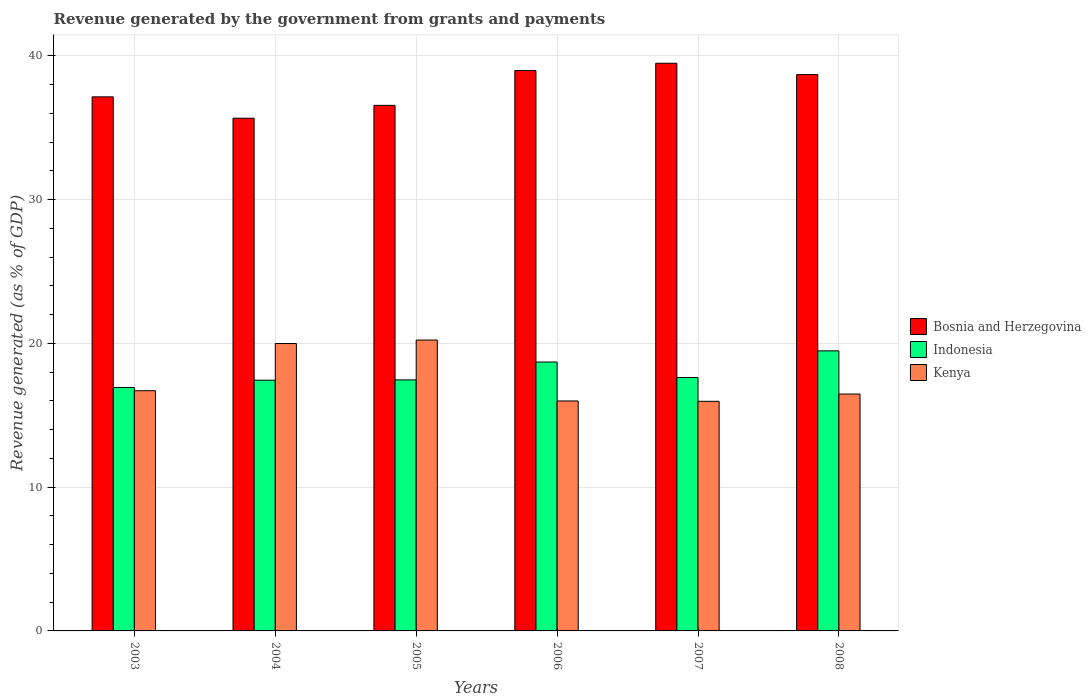Are the number of bars per tick equal to the number of legend labels?
Your response must be concise. Yes. Are the number of bars on each tick of the X-axis equal?
Your response must be concise. Yes. How many bars are there on the 5th tick from the left?
Keep it short and to the point. 3. How many bars are there on the 3rd tick from the right?
Give a very brief answer. 3. What is the label of the 4th group of bars from the left?
Offer a very short reply. 2006. What is the revenue generated by the government in Kenya in 2008?
Your answer should be very brief. 16.47. Across all years, what is the maximum revenue generated by the government in Indonesia?
Ensure brevity in your answer.  19.48. Across all years, what is the minimum revenue generated by the government in Bosnia and Herzegovina?
Ensure brevity in your answer.  35.66. In which year was the revenue generated by the government in Kenya maximum?
Ensure brevity in your answer.  2005. In which year was the revenue generated by the government in Bosnia and Herzegovina minimum?
Your answer should be compact. 2004. What is the total revenue generated by the government in Indonesia in the graph?
Give a very brief answer. 107.62. What is the difference between the revenue generated by the government in Kenya in 2006 and that in 2007?
Give a very brief answer. 0.02. What is the difference between the revenue generated by the government in Kenya in 2003 and the revenue generated by the government in Indonesia in 2005?
Offer a terse response. -0.75. What is the average revenue generated by the government in Bosnia and Herzegovina per year?
Your answer should be compact. 37.75. In the year 2007, what is the difference between the revenue generated by the government in Bosnia and Herzegovina and revenue generated by the government in Indonesia?
Ensure brevity in your answer.  21.85. In how many years, is the revenue generated by the government in Indonesia greater than 22 %?
Offer a terse response. 0. What is the ratio of the revenue generated by the government in Bosnia and Herzegovina in 2003 to that in 2008?
Give a very brief answer. 0.96. What is the difference between the highest and the second highest revenue generated by the government in Indonesia?
Your answer should be compact. 0.78. What is the difference between the highest and the lowest revenue generated by the government in Kenya?
Ensure brevity in your answer.  4.26. What does the 3rd bar from the right in 2006 represents?
Provide a succinct answer. Bosnia and Herzegovina. How many bars are there?
Provide a short and direct response. 18. How many years are there in the graph?
Ensure brevity in your answer.  6. What is the difference between two consecutive major ticks on the Y-axis?
Give a very brief answer. 10. Does the graph contain any zero values?
Keep it short and to the point. No. Does the graph contain grids?
Your answer should be compact. Yes. How many legend labels are there?
Ensure brevity in your answer.  3. How are the legend labels stacked?
Offer a very short reply. Vertical. What is the title of the graph?
Your response must be concise. Revenue generated by the government from grants and payments. What is the label or title of the X-axis?
Make the answer very short. Years. What is the label or title of the Y-axis?
Offer a very short reply. Revenue generated (as % of GDP). What is the Revenue generated (as % of GDP) of Bosnia and Herzegovina in 2003?
Keep it short and to the point. 37.14. What is the Revenue generated (as % of GDP) of Indonesia in 2003?
Your answer should be very brief. 16.93. What is the Revenue generated (as % of GDP) of Kenya in 2003?
Offer a very short reply. 16.7. What is the Revenue generated (as % of GDP) of Bosnia and Herzegovina in 2004?
Your response must be concise. 35.66. What is the Revenue generated (as % of GDP) in Indonesia in 2004?
Your answer should be very brief. 17.44. What is the Revenue generated (as % of GDP) in Kenya in 2004?
Offer a very short reply. 19.99. What is the Revenue generated (as % of GDP) in Bosnia and Herzegovina in 2005?
Make the answer very short. 36.55. What is the Revenue generated (as % of GDP) in Indonesia in 2005?
Offer a very short reply. 17.46. What is the Revenue generated (as % of GDP) of Kenya in 2005?
Your answer should be very brief. 20.23. What is the Revenue generated (as % of GDP) in Bosnia and Herzegovina in 2006?
Provide a short and direct response. 38.97. What is the Revenue generated (as % of GDP) of Indonesia in 2006?
Provide a short and direct response. 18.7. What is the Revenue generated (as % of GDP) in Kenya in 2006?
Your response must be concise. 15.99. What is the Revenue generated (as % of GDP) of Bosnia and Herzegovina in 2007?
Provide a short and direct response. 39.48. What is the Revenue generated (as % of GDP) in Indonesia in 2007?
Keep it short and to the point. 17.62. What is the Revenue generated (as % of GDP) of Kenya in 2007?
Keep it short and to the point. 15.97. What is the Revenue generated (as % of GDP) in Bosnia and Herzegovina in 2008?
Your response must be concise. 38.69. What is the Revenue generated (as % of GDP) of Indonesia in 2008?
Your answer should be compact. 19.48. What is the Revenue generated (as % of GDP) in Kenya in 2008?
Ensure brevity in your answer.  16.47. Across all years, what is the maximum Revenue generated (as % of GDP) in Bosnia and Herzegovina?
Your response must be concise. 39.48. Across all years, what is the maximum Revenue generated (as % of GDP) in Indonesia?
Your answer should be compact. 19.48. Across all years, what is the maximum Revenue generated (as % of GDP) in Kenya?
Offer a terse response. 20.23. Across all years, what is the minimum Revenue generated (as % of GDP) of Bosnia and Herzegovina?
Your answer should be compact. 35.66. Across all years, what is the minimum Revenue generated (as % of GDP) in Indonesia?
Give a very brief answer. 16.93. Across all years, what is the minimum Revenue generated (as % of GDP) of Kenya?
Provide a short and direct response. 15.97. What is the total Revenue generated (as % of GDP) in Bosnia and Herzegovina in the graph?
Your response must be concise. 226.48. What is the total Revenue generated (as % of GDP) in Indonesia in the graph?
Offer a terse response. 107.62. What is the total Revenue generated (as % of GDP) in Kenya in the graph?
Your response must be concise. 105.35. What is the difference between the Revenue generated (as % of GDP) of Bosnia and Herzegovina in 2003 and that in 2004?
Make the answer very short. 1.48. What is the difference between the Revenue generated (as % of GDP) of Indonesia in 2003 and that in 2004?
Offer a terse response. -0.51. What is the difference between the Revenue generated (as % of GDP) of Kenya in 2003 and that in 2004?
Give a very brief answer. -3.28. What is the difference between the Revenue generated (as % of GDP) in Bosnia and Herzegovina in 2003 and that in 2005?
Provide a succinct answer. 0.59. What is the difference between the Revenue generated (as % of GDP) of Indonesia in 2003 and that in 2005?
Your answer should be very brief. -0.53. What is the difference between the Revenue generated (as % of GDP) of Kenya in 2003 and that in 2005?
Your response must be concise. -3.52. What is the difference between the Revenue generated (as % of GDP) of Bosnia and Herzegovina in 2003 and that in 2006?
Offer a terse response. -1.83. What is the difference between the Revenue generated (as % of GDP) of Indonesia in 2003 and that in 2006?
Your answer should be very brief. -1.77. What is the difference between the Revenue generated (as % of GDP) of Kenya in 2003 and that in 2006?
Your answer should be very brief. 0.71. What is the difference between the Revenue generated (as % of GDP) of Bosnia and Herzegovina in 2003 and that in 2007?
Give a very brief answer. -2.34. What is the difference between the Revenue generated (as % of GDP) in Indonesia in 2003 and that in 2007?
Provide a succinct answer. -0.69. What is the difference between the Revenue generated (as % of GDP) in Kenya in 2003 and that in 2007?
Keep it short and to the point. 0.74. What is the difference between the Revenue generated (as % of GDP) of Bosnia and Herzegovina in 2003 and that in 2008?
Your answer should be compact. -1.55. What is the difference between the Revenue generated (as % of GDP) in Indonesia in 2003 and that in 2008?
Your answer should be compact. -2.55. What is the difference between the Revenue generated (as % of GDP) of Kenya in 2003 and that in 2008?
Keep it short and to the point. 0.23. What is the difference between the Revenue generated (as % of GDP) of Bosnia and Herzegovina in 2004 and that in 2005?
Your answer should be very brief. -0.89. What is the difference between the Revenue generated (as % of GDP) in Indonesia in 2004 and that in 2005?
Provide a succinct answer. -0.02. What is the difference between the Revenue generated (as % of GDP) in Kenya in 2004 and that in 2005?
Offer a very short reply. -0.24. What is the difference between the Revenue generated (as % of GDP) in Bosnia and Herzegovina in 2004 and that in 2006?
Provide a short and direct response. -3.31. What is the difference between the Revenue generated (as % of GDP) of Indonesia in 2004 and that in 2006?
Your response must be concise. -1.26. What is the difference between the Revenue generated (as % of GDP) of Kenya in 2004 and that in 2006?
Make the answer very short. 3.99. What is the difference between the Revenue generated (as % of GDP) of Bosnia and Herzegovina in 2004 and that in 2007?
Make the answer very short. -3.82. What is the difference between the Revenue generated (as % of GDP) in Indonesia in 2004 and that in 2007?
Provide a succinct answer. -0.19. What is the difference between the Revenue generated (as % of GDP) of Kenya in 2004 and that in 2007?
Your answer should be compact. 4.02. What is the difference between the Revenue generated (as % of GDP) in Bosnia and Herzegovina in 2004 and that in 2008?
Offer a very short reply. -3.03. What is the difference between the Revenue generated (as % of GDP) of Indonesia in 2004 and that in 2008?
Give a very brief answer. -2.04. What is the difference between the Revenue generated (as % of GDP) in Kenya in 2004 and that in 2008?
Ensure brevity in your answer.  3.51. What is the difference between the Revenue generated (as % of GDP) of Bosnia and Herzegovina in 2005 and that in 2006?
Make the answer very short. -2.42. What is the difference between the Revenue generated (as % of GDP) of Indonesia in 2005 and that in 2006?
Your answer should be very brief. -1.24. What is the difference between the Revenue generated (as % of GDP) of Kenya in 2005 and that in 2006?
Offer a very short reply. 4.24. What is the difference between the Revenue generated (as % of GDP) in Bosnia and Herzegovina in 2005 and that in 2007?
Provide a succinct answer. -2.93. What is the difference between the Revenue generated (as % of GDP) of Indonesia in 2005 and that in 2007?
Your response must be concise. -0.17. What is the difference between the Revenue generated (as % of GDP) in Kenya in 2005 and that in 2007?
Provide a short and direct response. 4.26. What is the difference between the Revenue generated (as % of GDP) of Bosnia and Herzegovina in 2005 and that in 2008?
Your response must be concise. -2.14. What is the difference between the Revenue generated (as % of GDP) of Indonesia in 2005 and that in 2008?
Offer a terse response. -2.02. What is the difference between the Revenue generated (as % of GDP) of Kenya in 2005 and that in 2008?
Give a very brief answer. 3.76. What is the difference between the Revenue generated (as % of GDP) in Bosnia and Herzegovina in 2006 and that in 2007?
Offer a very short reply. -0.51. What is the difference between the Revenue generated (as % of GDP) in Indonesia in 2006 and that in 2007?
Offer a very short reply. 1.08. What is the difference between the Revenue generated (as % of GDP) in Kenya in 2006 and that in 2007?
Offer a terse response. 0.02. What is the difference between the Revenue generated (as % of GDP) of Bosnia and Herzegovina in 2006 and that in 2008?
Your answer should be very brief. 0.28. What is the difference between the Revenue generated (as % of GDP) of Indonesia in 2006 and that in 2008?
Make the answer very short. -0.78. What is the difference between the Revenue generated (as % of GDP) of Kenya in 2006 and that in 2008?
Offer a very short reply. -0.48. What is the difference between the Revenue generated (as % of GDP) of Bosnia and Herzegovina in 2007 and that in 2008?
Make the answer very short. 0.79. What is the difference between the Revenue generated (as % of GDP) of Indonesia in 2007 and that in 2008?
Your answer should be very brief. -1.85. What is the difference between the Revenue generated (as % of GDP) of Kenya in 2007 and that in 2008?
Your answer should be very brief. -0.5. What is the difference between the Revenue generated (as % of GDP) in Bosnia and Herzegovina in 2003 and the Revenue generated (as % of GDP) in Indonesia in 2004?
Offer a terse response. 19.7. What is the difference between the Revenue generated (as % of GDP) in Bosnia and Herzegovina in 2003 and the Revenue generated (as % of GDP) in Kenya in 2004?
Ensure brevity in your answer.  17.15. What is the difference between the Revenue generated (as % of GDP) of Indonesia in 2003 and the Revenue generated (as % of GDP) of Kenya in 2004?
Your answer should be compact. -3.06. What is the difference between the Revenue generated (as % of GDP) in Bosnia and Herzegovina in 2003 and the Revenue generated (as % of GDP) in Indonesia in 2005?
Ensure brevity in your answer.  19.68. What is the difference between the Revenue generated (as % of GDP) in Bosnia and Herzegovina in 2003 and the Revenue generated (as % of GDP) in Kenya in 2005?
Offer a very short reply. 16.91. What is the difference between the Revenue generated (as % of GDP) of Indonesia in 2003 and the Revenue generated (as % of GDP) of Kenya in 2005?
Give a very brief answer. -3.3. What is the difference between the Revenue generated (as % of GDP) of Bosnia and Herzegovina in 2003 and the Revenue generated (as % of GDP) of Indonesia in 2006?
Provide a short and direct response. 18.44. What is the difference between the Revenue generated (as % of GDP) in Bosnia and Herzegovina in 2003 and the Revenue generated (as % of GDP) in Kenya in 2006?
Make the answer very short. 21.15. What is the difference between the Revenue generated (as % of GDP) of Indonesia in 2003 and the Revenue generated (as % of GDP) of Kenya in 2006?
Offer a terse response. 0.94. What is the difference between the Revenue generated (as % of GDP) in Bosnia and Herzegovina in 2003 and the Revenue generated (as % of GDP) in Indonesia in 2007?
Provide a succinct answer. 19.52. What is the difference between the Revenue generated (as % of GDP) of Bosnia and Herzegovina in 2003 and the Revenue generated (as % of GDP) of Kenya in 2007?
Your answer should be compact. 21.17. What is the difference between the Revenue generated (as % of GDP) in Indonesia in 2003 and the Revenue generated (as % of GDP) in Kenya in 2007?
Give a very brief answer. 0.96. What is the difference between the Revenue generated (as % of GDP) of Bosnia and Herzegovina in 2003 and the Revenue generated (as % of GDP) of Indonesia in 2008?
Keep it short and to the point. 17.66. What is the difference between the Revenue generated (as % of GDP) in Bosnia and Herzegovina in 2003 and the Revenue generated (as % of GDP) in Kenya in 2008?
Offer a very short reply. 20.67. What is the difference between the Revenue generated (as % of GDP) in Indonesia in 2003 and the Revenue generated (as % of GDP) in Kenya in 2008?
Your answer should be compact. 0.46. What is the difference between the Revenue generated (as % of GDP) in Bosnia and Herzegovina in 2004 and the Revenue generated (as % of GDP) in Indonesia in 2005?
Make the answer very short. 18.2. What is the difference between the Revenue generated (as % of GDP) of Bosnia and Herzegovina in 2004 and the Revenue generated (as % of GDP) of Kenya in 2005?
Your answer should be very brief. 15.43. What is the difference between the Revenue generated (as % of GDP) of Indonesia in 2004 and the Revenue generated (as % of GDP) of Kenya in 2005?
Offer a terse response. -2.79. What is the difference between the Revenue generated (as % of GDP) of Bosnia and Herzegovina in 2004 and the Revenue generated (as % of GDP) of Indonesia in 2006?
Give a very brief answer. 16.96. What is the difference between the Revenue generated (as % of GDP) of Bosnia and Herzegovina in 2004 and the Revenue generated (as % of GDP) of Kenya in 2006?
Provide a short and direct response. 19.66. What is the difference between the Revenue generated (as % of GDP) in Indonesia in 2004 and the Revenue generated (as % of GDP) in Kenya in 2006?
Your response must be concise. 1.44. What is the difference between the Revenue generated (as % of GDP) of Bosnia and Herzegovina in 2004 and the Revenue generated (as % of GDP) of Indonesia in 2007?
Your answer should be very brief. 18.03. What is the difference between the Revenue generated (as % of GDP) in Bosnia and Herzegovina in 2004 and the Revenue generated (as % of GDP) in Kenya in 2007?
Give a very brief answer. 19.69. What is the difference between the Revenue generated (as % of GDP) in Indonesia in 2004 and the Revenue generated (as % of GDP) in Kenya in 2007?
Your response must be concise. 1.47. What is the difference between the Revenue generated (as % of GDP) of Bosnia and Herzegovina in 2004 and the Revenue generated (as % of GDP) of Indonesia in 2008?
Provide a succinct answer. 16.18. What is the difference between the Revenue generated (as % of GDP) in Bosnia and Herzegovina in 2004 and the Revenue generated (as % of GDP) in Kenya in 2008?
Provide a succinct answer. 19.18. What is the difference between the Revenue generated (as % of GDP) of Indonesia in 2004 and the Revenue generated (as % of GDP) of Kenya in 2008?
Give a very brief answer. 0.96. What is the difference between the Revenue generated (as % of GDP) of Bosnia and Herzegovina in 2005 and the Revenue generated (as % of GDP) of Indonesia in 2006?
Give a very brief answer. 17.85. What is the difference between the Revenue generated (as % of GDP) in Bosnia and Herzegovina in 2005 and the Revenue generated (as % of GDP) in Kenya in 2006?
Keep it short and to the point. 20.56. What is the difference between the Revenue generated (as % of GDP) of Indonesia in 2005 and the Revenue generated (as % of GDP) of Kenya in 2006?
Make the answer very short. 1.46. What is the difference between the Revenue generated (as % of GDP) of Bosnia and Herzegovina in 2005 and the Revenue generated (as % of GDP) of Indonesia in 2007?
Offer a very short reply. 18.93. What is the difference between the Revenue generated (as % of GDP) in Bosnia and Herzegovina in 2005 and the Revenue generated (as % of GDP) in Kenya in 2007?
Ensure brevity in your answer.  20.58. What is the difference between the Revenue generated (as % of GDP) in Indonesia in 2005 and the Revenue generated (as % of GDP) in Kenya in 2007?
Provide a short and direct response. 1.49. What is the difference between the Revenue generated (as % of GDP) of Bosnia and Herzegovina in 2005 and the Revenue generated (as % of GDP) of Indonesia in 2008?
Give a very brief answer. 17.07. What is the difference between the Revenue generated (as % of GDP) in Bosnia and Herzegovina in 2005 and the Revenue generated (as % of GDP) in Kenya in 2008?
Offer a terse response. 20.08. What is the difference between the Revenue generated (as % of GDP) in Indonesia in 2005 and the Revenue generated (as % of GDP) in Kenya in 2008?
Provide a short and direct response. 0.98. What is the difference between the Revenue generated (as % of GDP) in Bosnia and Herzegovina in 2006 and the Revenue generated (as % of GDP) in Indonesia in 2007?
Your response must be concise. 21.35. What is the difference between the Revenue generated (as % of GDP) of Bosnia and Herzegovina in 2006 and the Revenue generated (as % of GDP) of Kenya in 2007?
Provide a succinct answer. 23. What is the difference between the Revenue generated (as % of GDP) of Indonesia in 2006 and the Revenue generated (as % of GDP) of Kenya in 2007?
Your answer should be compact. 2.73. What is the difference between the Revenue generated (as % of GDP) of Bosnia and Herzegovina in 2006 and the Revenue generated (as % of GDP) of Indonesia in 2008?
Make the answer very short. 19.49. What is the difference between the Revenue generated (as % of GDP) in Bosnia and Herzegovina in 2006 and the Revenue generated (as % of GDP) in Kenya in 2008?
Make the answer very short. 22.5. What is the difference between the Revenue generated (as % of GDP) in Indonesia in 2006 and the Revenue generated (as % of GDP) in Kenya in 2008?
Ensure brevity in your answer.  2.23. What is the difference between the Revenue generated (as % of GDP) of Bosnia and Herzegovina in 2007 and the Revenue generated (as % of GDP) of Indonesia in 2008?
Provide a succinct answer. 20. What is the difference between the Revenue generated (as % of GDP) of Bosnia and Herzegovina in 2007 and the Revenue generated (as % of GDP) of Kenya in 2008?
Your answer should be compact. 23. What is the difference between the Revenue generated (as % of GDP) of Indonesia in 2007 and the Revenue generated (as % of GDP) of Kenya in 2008?
Keep it short and to the point. 1.15. What is the average Revenue generated (as % of GDP) of Bosnia and Herzegovina per year?
Provide a succinct answer. 37.75. What is the average Revenue generated (as % of GDP) in Indonesia per year?
Offer a terse response. 17.94. What is the average Revenue generated (as % of GDP) in Kenya per year?
Provide a short and direct response. 17.56. In the year 2003, what is the difference between the Revenue generated (as % of GDP) in Bosnia and Herzegovina and Revenue generated (as % of GDP) in Indonesia?
Your answer should be very brief. 20.21. In the year 2003, what is the difference between the Revenue generated (as % of GDP) of Bosnia and Herzegovina and Revenue generated (as % of GDP) of Kenya?
Offer a terse response. 20.44. In the year 2003, what is the difference between the Revenue generated (as % of GDP) of Indonesia and Revenue generated (as % of GDP) of Kenya?
Offer a very short reply. 0.22. In the year 2004, what is the difference between the Revenue generated (as % of GDP) of Bosnia and Herzegovina and Revenue generated (as % of GDP) of Indonesia?
Offer a terse response. 18.22. In the year 2004, what is the difference between the Revenue generated (as % of GDP) in Bosnia and Herzegovina and Revenue generated (as % of GDP) in Kenya?
Your response must be concise. 15.67. In the year 2004, what is the difference between the Revenue generated (as % of GDP) of Indonesia and Revenue generated (as % of GDP) of Kenya?
Give a very brief answer. -2.55. In the year 2005, what is the difference between the Revenue generated (as % of GDP) of Bosnia and Herzegovina and Revenue generated (as % of GDP) of Indonesia?
Your answer should be very brief. 19.09. In the year 2005, what is the difference between the Revenue generated (as % of GDP) in Bosnia and Herzegovina and Revenue generated (as % of GDP) in Kenya?
Give a very brief answer. 16.32. In the year 2005, what is the difference between the Revenue generated (as % of GDP) in Indonesia and Revenue generated (as % of GDP) in Kenya?
Provide a succinct answer. -2.77. In the year 2006, what is the difference between the Revenue generated (as % of GDP) of Bosnia and Herzegovina and Revenue generated (as % of GDP) of Indonesia?
Your response must be concise. 20.27. In the year 2006, what is the difference between the Revenue generated (as % of GDP) of Bosnia and Herzegovina and Revenue generated (as % of GDP) of Kenya?
Offer a very short reply. 22.98. In the year 2006, what is the difference between the Revenue generated (as % of GDP) in Indonesia and Revenue generated (as % of GDP) in Kenya?
Your response must be concise. 2.71. In the year 2007, what is the difference between the Revenue generated (as % of GDP) in Bosnia and Herzegovina and Revenue generated (as % of GDP) in Indonesia?
Give a very brief answer. 21.86. In the year 2007, what is the difference between the Revenue generated (as % of GDP) in Bosnia and Herzegovina and Revenue generated (as % of GDP) in Kenya?
Your response must be concise. 23.51. In the year 2007, what is the difference between the Revenue generated (as % of GDP) in Indonesia and Revenue generated (as % of GDP) in Kenya?
Offer a very short reply. 1.65. In the year 2008, what is the difference between the Revenue generated (as % of GDP) in Bosnia and Herzegovina and Revenue generated (as % of GDP) in Indonesia?
Provide a short and direct response. 19.21. In the year 2008, what is the difference between the Revenue generated (as % of GDP) in Bosnia and Herzegovina and Revenue generated (as % of GDP) in Kenya?
Your answer should be compact. 22.22. In the year 2008, what is the difference between the Revenue generated (as % of GDP) in Indonesia and Revenue generated (as % of GDP) in Kenya?
Your answer should be very brief. 3. What is the ratio of the Revenue generated (as % of GDP) in Bosnia and Herzegovina in 2003 to that in 2004?
Offer a very short reply. 1.04. What is the ratio of the Revenue generated (as % of GDP) of Indonesia in 2003 to that in 2004?
Provide a short and direct response. 0.97. What is the ratio of the Revenue generated (as % of GDP) in Kenya in 2003 to that in 2004?
Your answer should be very brief. 0.84. What is the ratio of the Revenue generated (as % of GDP) in Bosnia and Herzegovina in 2003 to that in 2005?
Make the answer very short. 1.02. What is the ratio of the Revenue generated (as % of GDP) in Indonesia in 2003 to that in 2005?
Offer a very short reply. 0.97. What is the ratio of the Revenue generated (as % of GDP) of Kenya in 2003 to that in 2005?
Provide a succinct answer. 0.83. What is the ratio of the Revenue generated (as % of GDP) of Bosnia and Herzegovina in 2003 to that in 2006?
Your answer should be compact. 0.95. What is the ratio of the Revenue generated (as % of GDP) of Indonesia in 2003 to that in 2006?
Keep it short and to the point. 0.91. What is the ratio of the Revenue generated (as % of GDP) of Kenya in 2003 to that in 2006?
Your answer should be very brief. 1.04. What is the ratio of the Revenue generated (as % of GDP) in Bosnia and Herzegovina in 2003 to that in 2007?
Give a very brief answer. 0.94. What is the ratio of the Revenue generated (as % of GDP) of Indonesia in 2003 to that in 2007?
Provide a short and direct response. 0.96. What is the ratio of the Revenue generated (as % of GDP) of Kenya in 2003 to that in 2007?
Your response must be concise. 1.05. What is the ratio of the Revenue generated (as % of GDP) of Bosnia and Herzegovina in 2003 to that in 2008?
Make the answer very short. 0.96. What is the ratio of the Revenue generated (as % of GDP) of Indonesia in 2003 to that in 2008?
Offer a terse response. 0.87. What is the ratio of the Revenue generated (as % of GDP) of Kenya in 2003 to that in 2008?
Make the answer very short. 1.01. What is the ratio of the Revenue generated (as % of GDP) of Bosnia and Herzegovina in 2004 to that in 2005?
Give a very brief answer. 0.98. What is the ratio of the Revenue generated (as % of GDP) in Indonesia in 2004 to that in 2005?
Your response must be concise. 1. What is the ratio of the Revenue generated (as % of GDP) in Bosnia and Herzegovina in 2004 to that in 2006?
Ensure brevity in your answer.  0.92. What is the ratio of the Revenue generated (as % of GDP) of Indonesia in 2004 to that in 2006?
Your answer should be very brief. 0.93. What is the ratio of the Revenue generated (as % of GDP) of Kenya in 2004 to that in 2006?
Provide a succinct answer. 1.25. What is the ratio of the Revenue generated (as % of GDP) of Bosnia and Herzegovina in 2004 to that in 2007?
Ensure brevity in your answer.  0.9. What is the ratio of the Revenue generated (as % of GDP) of Indonesia in 2004 to that in 2007?
Your response must be concise. 0.99. What is the ratio of the Revenue generated (as % of GDP) in Kenya in 2004 to that in 2007?
Your answer should be compact. 1.25. What is the ratio of the Revenue generated (as % of GDP) in Bosnia and Herzegovina in 2004 to that in 2008?
Your answer should be compact. 0.92. What is the ratio of the Revenue generated (as % of GDP) in Indonesia in 2004 to that in 2008?
Ensure brevity in your answer.  0.9. What is the ratio of the Revenue generated (as % of GDP) of Kenya in 2004 to that in 2008?
Make the answer very short. 1.21. What is the ratio of the Revenue generated (as % of GDP) of Bosnia and Herzegovina in 2005 to that in 2006?
Ensure brevity in your answer.  0.94. What is the ratio of the Revenue generated (as % of GDP) in Indonesia in 2005 to that in 2006?
Keep it short and to the point. 0.93. What is the ratio of the Revenue generated (as % of GDP) of Kenya in 2005 to that in 2006?
Provide a succinct answer. 1.26. What is the ratio of the Revenue generated (as % of GDP) in Bosnia and Herzegovina in 2005 to that in 2007?
Make the answer very short. 0.93. What is the ratio of the Revenue generated (as % of GDP) of Indonesia in 2005 to that in 2007?
Offer a terse response. 0.99. What is the ratio of the Revenue generated (as % of GDP) of Kenya in 2005 to that in 2007?
Offer a terse response. 1.27. What is the ratio of the Revenue generated (as % of GDP) of Bosnia and Herzegovina in 2005 to that in 2008?
Your answer should be very brief. 0.94. What is the ratio of the Revenue generated (as % of GDP) of Indonesia in 2005 to that in 2008?
Keep it short and to the point. 0.9. What is the ratio of the Revenue generated (as % of GDP) of Kenya in 2005 to that in 2008?
Make the answer very short. 1.23. What is the ratio of the Revenue generated (as % of GDP) in Bosnia and Herzegovina in 2006 to that in 2007?
Offer a very short reply. 0.99. What is the ratio of the Revenue generated (as % of GDP) of Indonesia in 2006 to that in 2007?
Keep it short and to the point. 1.06. What is the ratio of the Revenue generated (as % of GDP) of Indonesia in 2006 to that in 2008?
Offer a very short reply. 0.96. What is the ratio of the Revenue generated (as % of GDP) in Kenya in 2006 to that in 2008?
Ensure brevity in your answer.  0.97. What is the ratio of the Revenue generated (as % of GDP) of Bosnia and Herzegovina in 2007 to that in 2008?
Your answer should be compact. 1.02. What is the ratio of the Revenue generated (as % of GDP) in Indonesia in 2007 to that in 2008?
Ensure brevity in your answer.  0.9. What is the ratio of the Revenue generated (as % of GDP) of Kenya in 2007 to that in 2008?
Offer a terse response. 0.97. What is the difference between the highest and the second highest Revenue generated (as % of GDP) in Bosnia and Herzegovina?
Offer a very short reply. 0.51. What is the difference between the highest and the second highest Revenue generated (as % of GDP) in Indonesia?
Provide a short and direct response. 0.78. What is the difference between the highest and the second highest Revenue generated (as % of GDP) in Kenya?
Provide a short and direct response. 0.24. What is the difference between the highest and the lowest Revenue generated (as % of GDP) of Bosnia and Herzegovina?
Your answer should be very brief. 3.82. What is the difference between the highest and the lowest Revenue generated (as % of GDP) of Indonesia?
Provide a succinct answer. 2.55. What is the difference between the highest and the lowest Revenue generated (as % of GDP) of Kenya?
Make the answer very short. 4.26. 